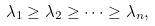Convert formula to latex. <formula><loc_0><loc_0><loc_500><loc_500>\lambda _ { 1 } \geq \lambda _ { 2 } \geq \cdots \geq \lambda _ { n } ,</formula> 